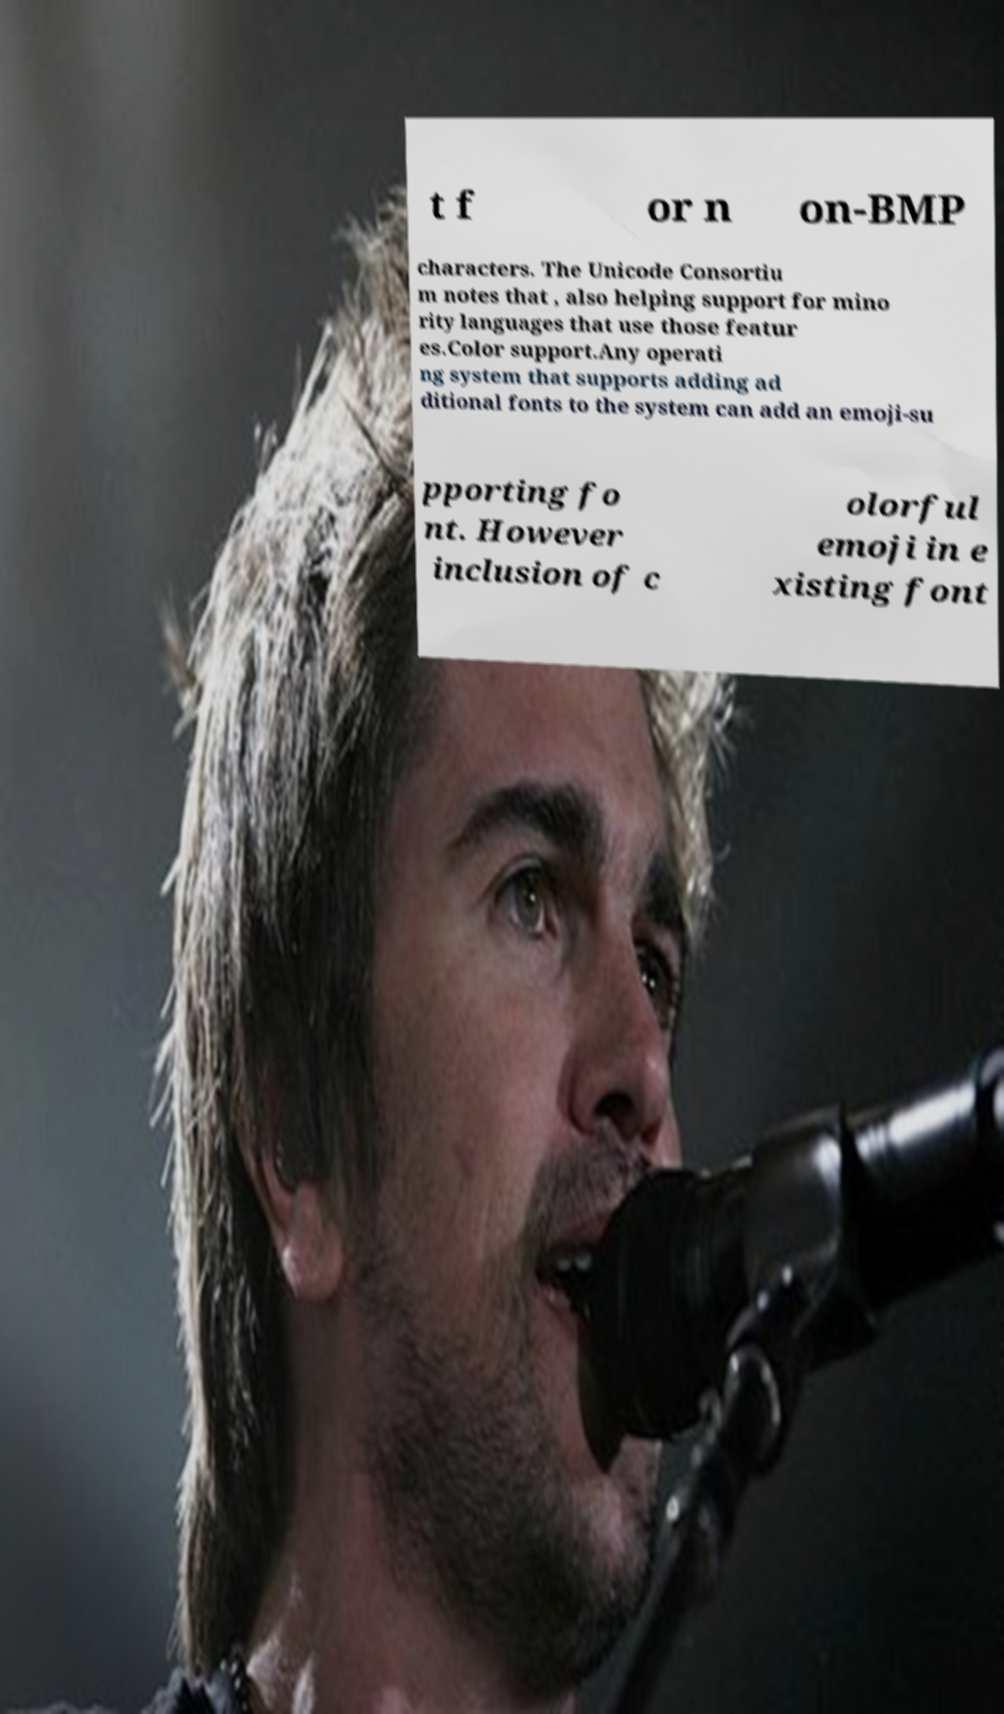I need the written content from this picture converted into text. Can you do that? t f or n on-BMP characters. The Unicode Consortiu m notes that , also helping support for mino rity languages that use those featur es.Color support.Any operati ng system that supports adding ad ditional fonts to the system can add an emoji-su pporting fo nt. However inclusion of c olorful emoji in e xisting font 